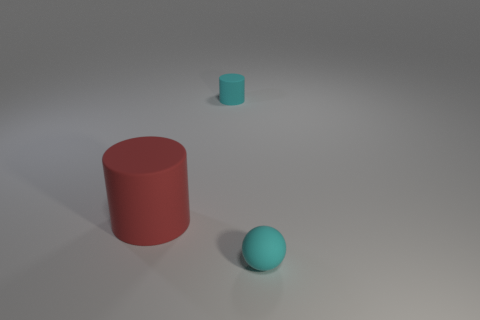Subtract all spheres. How many objects are left? 2 Add 3 big shiny cylinders. How many objects exist? 6 Subtract all rubber objects. Subtract all small green matte cylinders. How many objects are left? 0 Add 1 tiny cyan rubber spheres. How many tiny cyan rubber spheres are left? 2 Add 2 green metallic blocks. How many green metallic blocks exist? 2 Subtract 0 blue blocks. How many objects are left? 3 